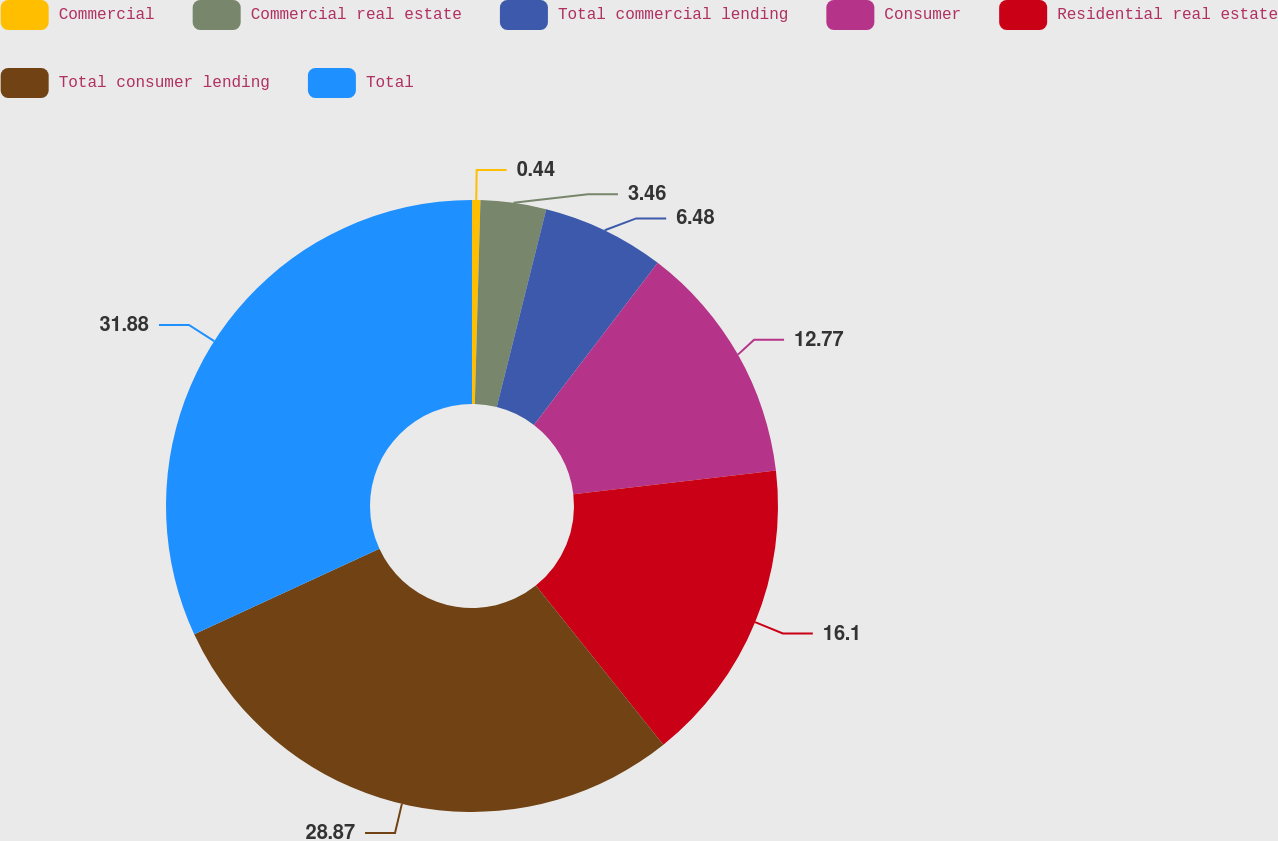Convert chart. <chart><loc_0><loc_0><loc_500><loc_500><pie_chart><fcel>Commercial<fcel>Commercial real estate<fcel>Total commercial lending<fcel>Consumer<fcel>Residential real estate<fcel>Total consumer lending<fcel>Total<nl><fcel>0.44%<fcel>3.46%<fcel>6.48%<fcel>12.77%<fcel>16.1%<fcel>28.87%<fcel>31.89%<nl></chart> 